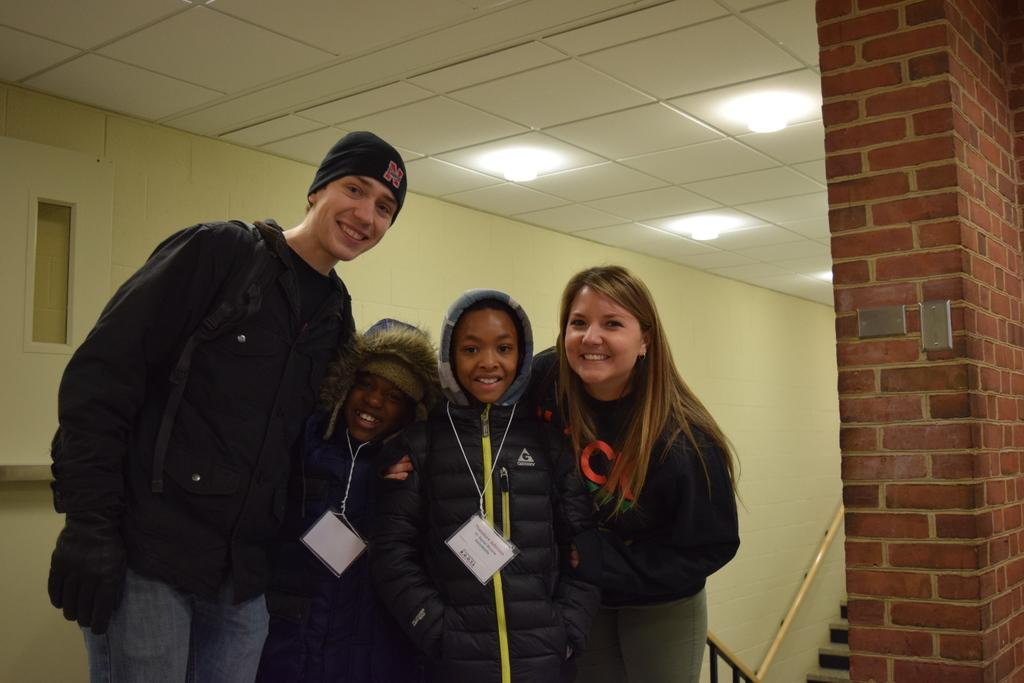What are the people in the image doing? The people in the image are standing and smiling. What can be seen in the background of the image? There is a wall and lights visible in the background of the image. What architectural feature is present at the bottom of the image? There are stairs at the bottom of the image. What type of bomb can be seen in the image? There is no bomb present in the image. What is the zinc content of the stairs in the image? There is no information about the zinc content of the stairs in the image. 